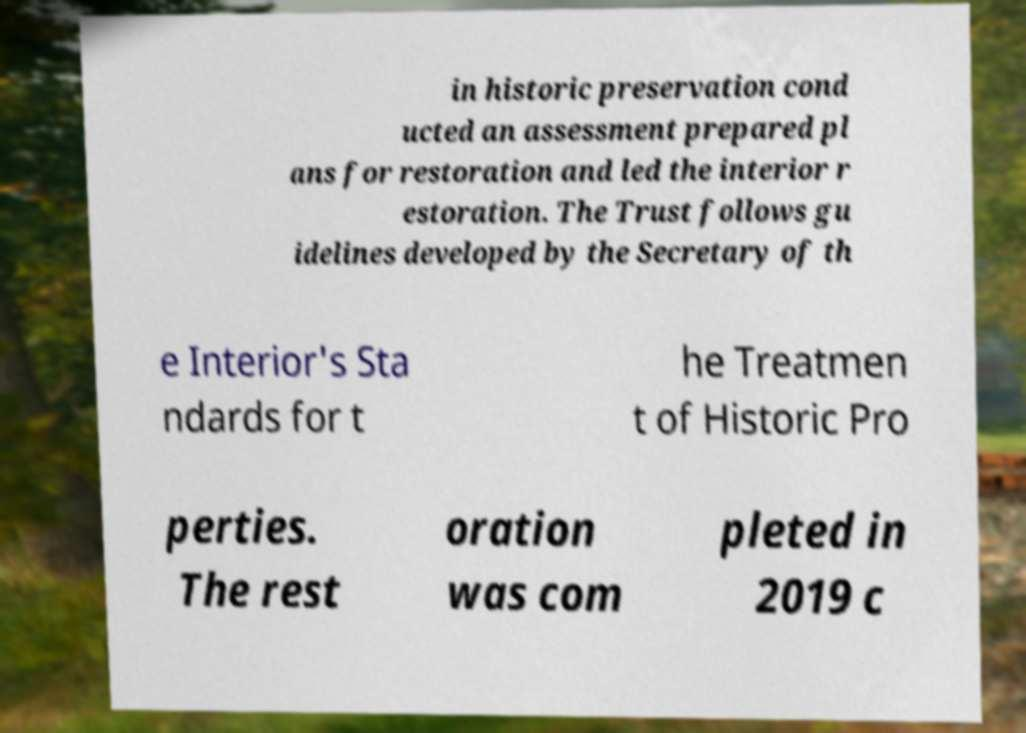Could you extract and type out the text from this image? in historic preservation cond ucted an assessment prepared pl ans for restoration and led the interior r estoration. The Trust follows gu idelines developed by the Secretary of th e Interior's Sta ndards for t he Treatmen t of Historic Pro perties. The rest oration was com pleted in 2019 c 